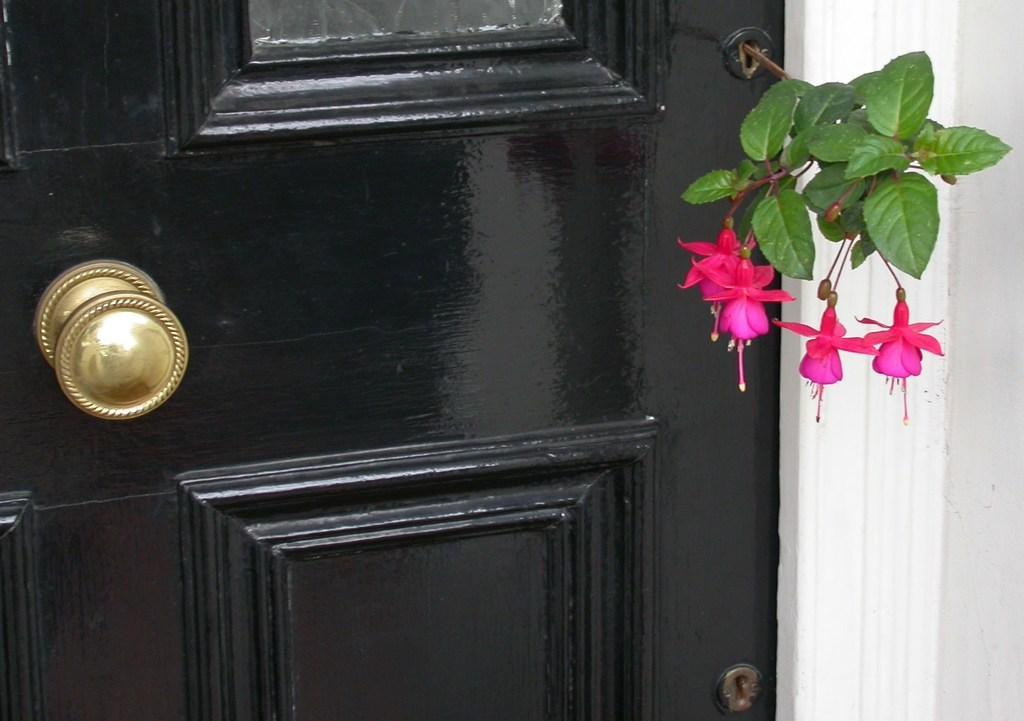What is one of the main features of the image? There is a door in the image. What type of decorative elements can be seen in the image? There are flowers in the image. What type of structure is visible in the image? There is a wall in the image. What type of tray is being used to measure the flowers in the image? There is no tray or measurement of flowers present in the image. 